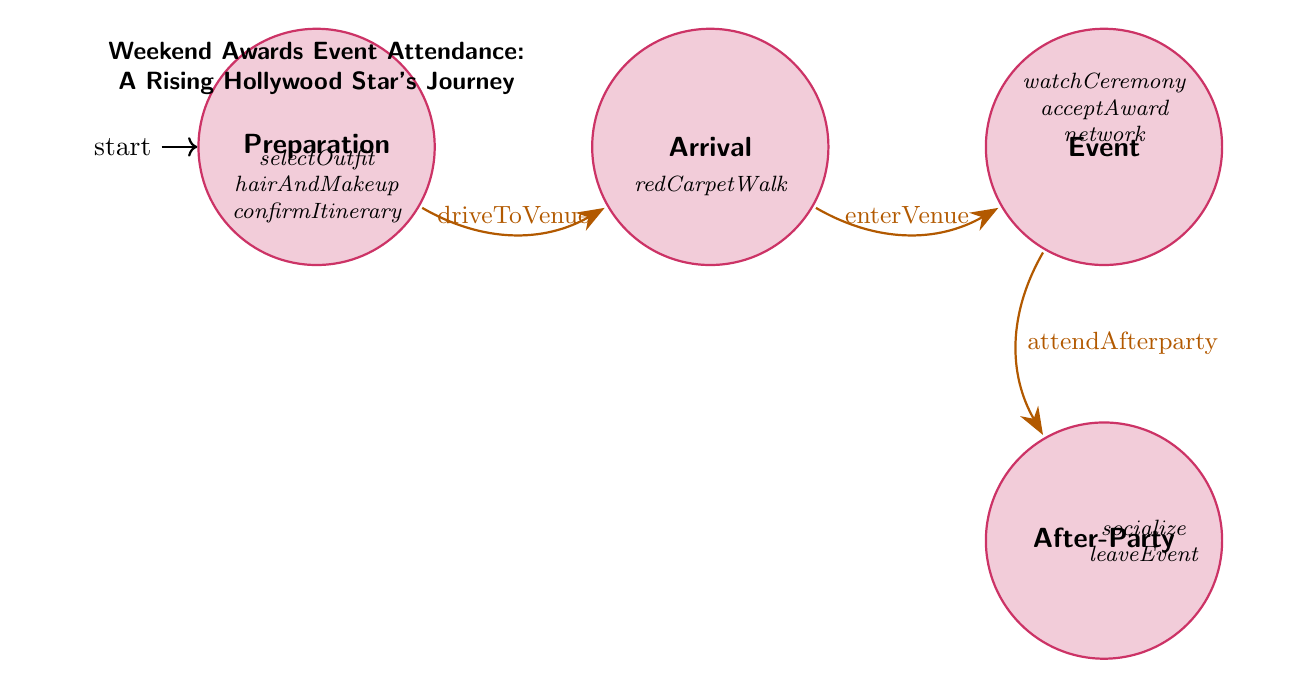What are the four main states in the diagram? The states listed in the diagram are Preparation, Arrival, Event, and After-Party. The diagram visually outlines these four main stages that a Hollywood star goes through during the weekend awards event.
Answer: Preparation, Arrival, Event, After-Party How many actions are there in the Preparation state? The Preparation state lists three actions: selectOutfit, hairAndMakeup, and confirmItinerary. This count is derived directly from the actions listed under the Preparation node in the diagram.
Answer: 3 What action follows the Arrival state? The action that follows the Arrival state is enterVenue, which is shown as the transition from Arrival to Event. This is indicated by the arrow connecting these two states indicating the sequence of events.
Answer: enterVenue What is the last state after the Event state? The last state after Event is After-Party, as indicated by the transition leading downwards from Event to After-Party, marking the conclusion of the award event activities.
Answer: After-Party How many transitions are present in the diagram? There are three transitions illustrated in the diagram: from Preparation to Arrival, from Arrival to Event, and from Event to After-Party. This count comes from visually counting each arrow that connects the states.
Answer: 3 Which state involves red carpet activities? The Arrival state involves the action redCarpetWalk, as indicated under its listed actions. This specifies that it's during the Arrival stage where the red carpet activities take place.
Answer: Arrival What is the first action in the After-Party state? The first action in the After-Party state is attendAfterparty. This is the initial action listed for this state, indicating engagement at the VIP after-party.
Answer: attendAfterparty Which action is indicated for the Event state? The Event state includes the action acceptAward, which signifies that if the star wins, they deliver their acceptance speech during this stage of the event. This is one of the critical actions listed for the Event state.
Answer: acceptAward What is the primary purpose of the network action? The primary purpose of the network action in the Event state is to engage and mingle with peers and notable industry figures, facilitating important connections during the awards event.
Answer: mingle with peers 